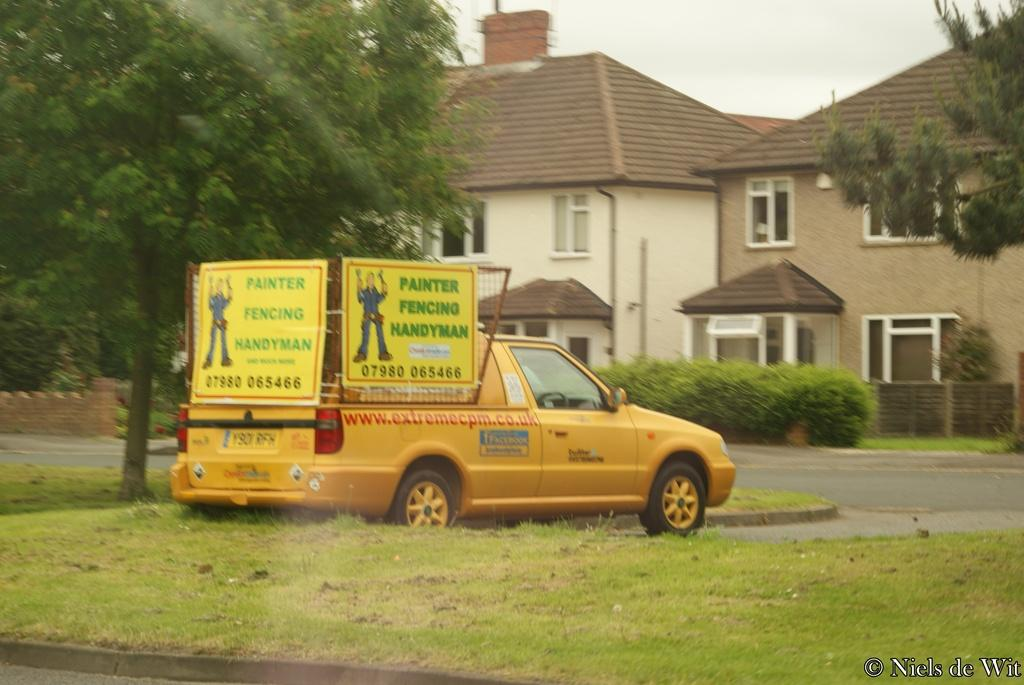What color is the vehicle in the image? The vehicle in the image is yellow. Where is the vehicle located? The vehicle is on the grass. What else can be seen near the vehicle? There are boards near the vehicle. What can be seen in the background of the image? There are many trees, houses with windows, and the sky visible in the background of the image. What scientific experiment is being conducted with the doll in the image? There is no doll present in the image, and therefore no scientific experiment involving a doll can be observed. 